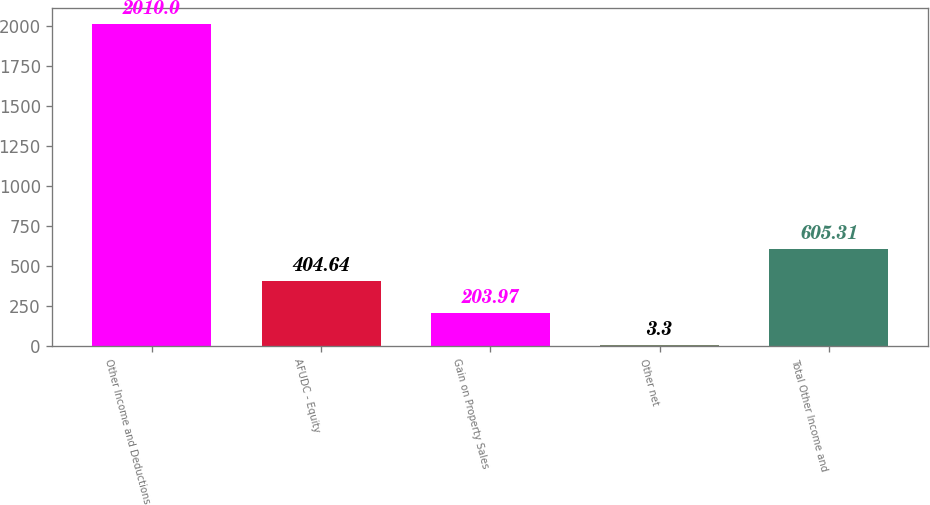Convert chart. <chart><loc_0><loc_0><loc_500><loc_500><bar_chart><fcel>Other Income and Deductions<fcel>AFUDC - Equity<fcel>Gain on Property Sales<fcel>Other net<fcel>Total Other Income and<nl><fcel>2010<fcel>404.64<fcel>203.97<fcel>3.3<fcel>605.31<nl></chart> 